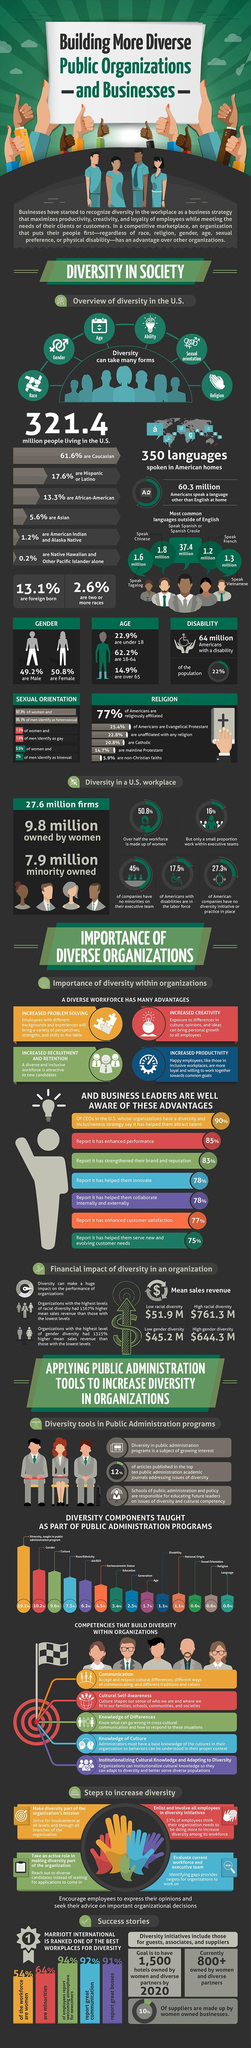What percent of US companies have no diversity initiative or practice?
Answer the question with a short phrase. 27.3% How many people in the US speak Spanish or Spanish Creole at their homes? 37.4 million What is the percentage of Americans with disabilities in the workforce? 17.5% Nearly 23% percent of the US population belong to which age group? under 18 Which language is spoken by 1.6 million people at their homes in the US? Tagalog What has advantages like increased productivity and increased creativity? A diverse workforce What percentage of the US workforce is made up of women? 50.8% What percent of the US population live with a disability? 22% How many people in the US speak Vietnamese at their homes? 1.3 million What percent of the American population are senior citizens? 14.9% 